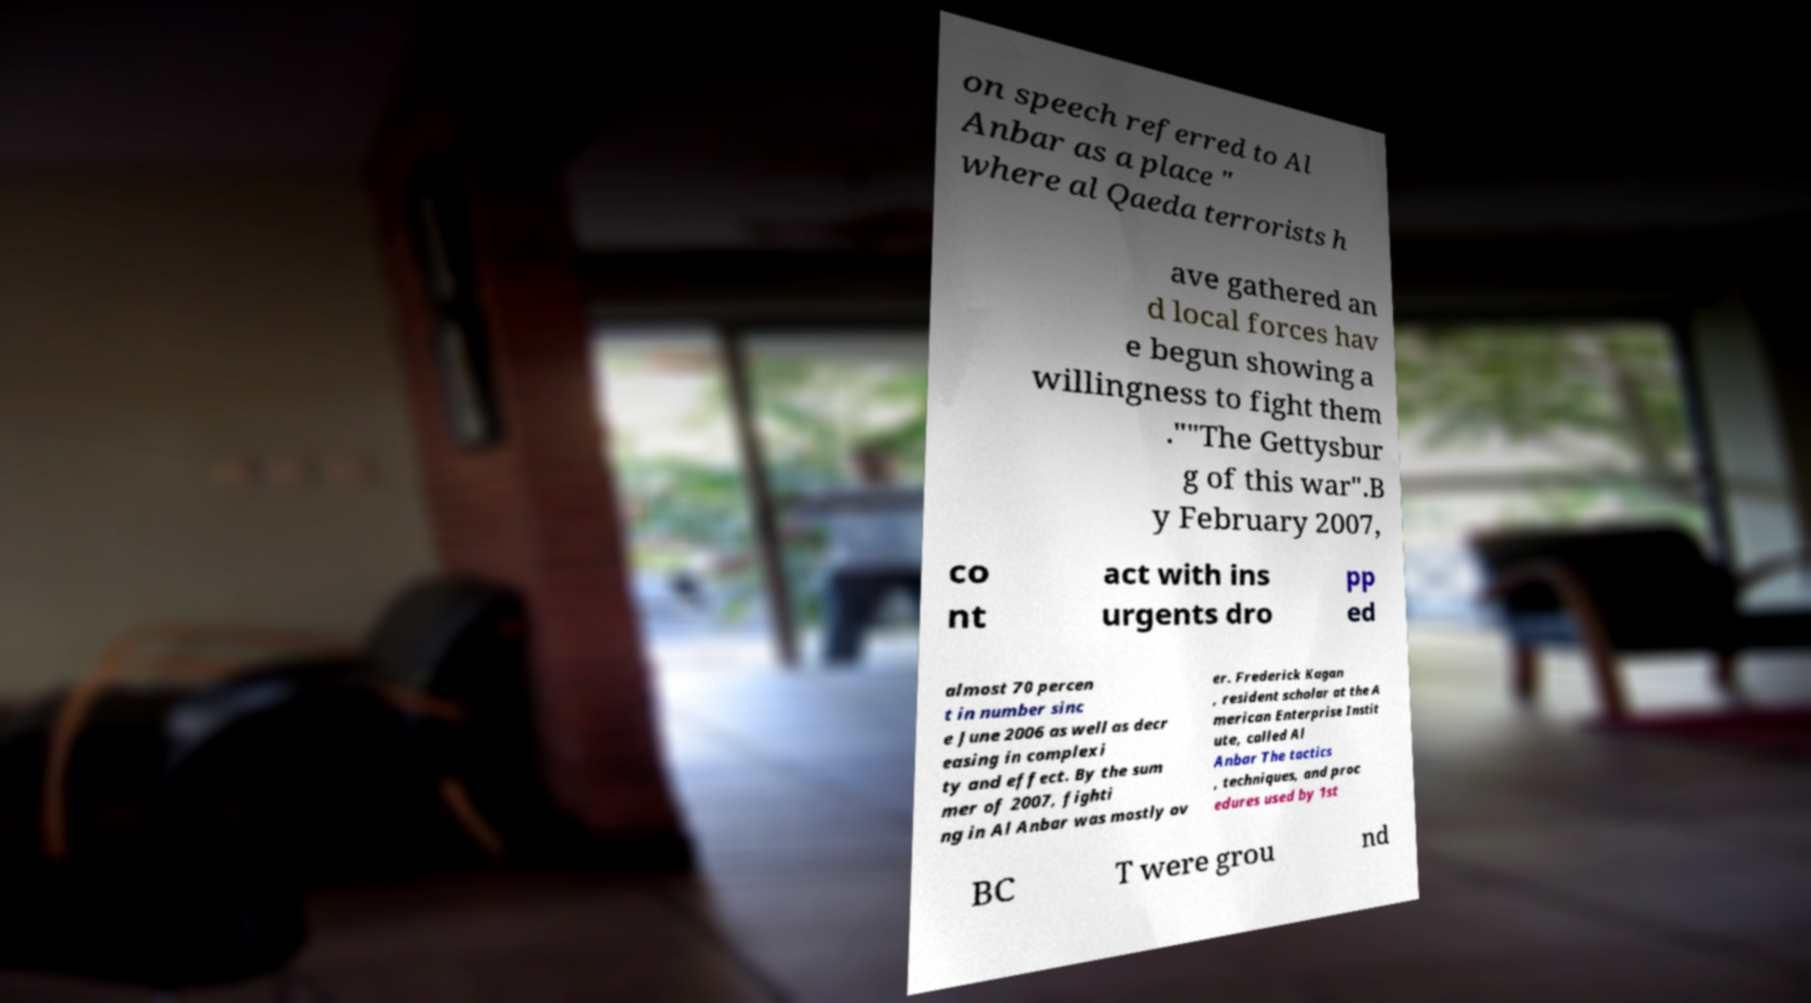For documentation purposes, I need the text within this image transcribed. Could you provide that? on speech referred to Al Anbar as a place " where al Qaeda terrorists h ave gathered an d local forces hav e begun showing a willingness to fight them .""The Gettysbur g of this war".B y February 2007, co nt act with ins urgents dro pp ed almost 70 percen t in number sinc e June 2006 as well as decr easing in complexi ty and effect. By the sum mer of 2007, fighti ng in Al Anbar was mostly ov er. Frederick Kagan , resident scholar at the A merican Enterprise Instit ute, called Al Anbar The tactics , techniques, and proc edures used by 1st BC T were grou nd 